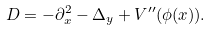Convert formula to latex. <formula><loc_0><loc_0><loc_500><loc_500>D = - \partial ^ { 2 } _ { x } - \Delta _ { y } + V ^ { \prime \prime } ( \phi ( x ) ) .</formula> 